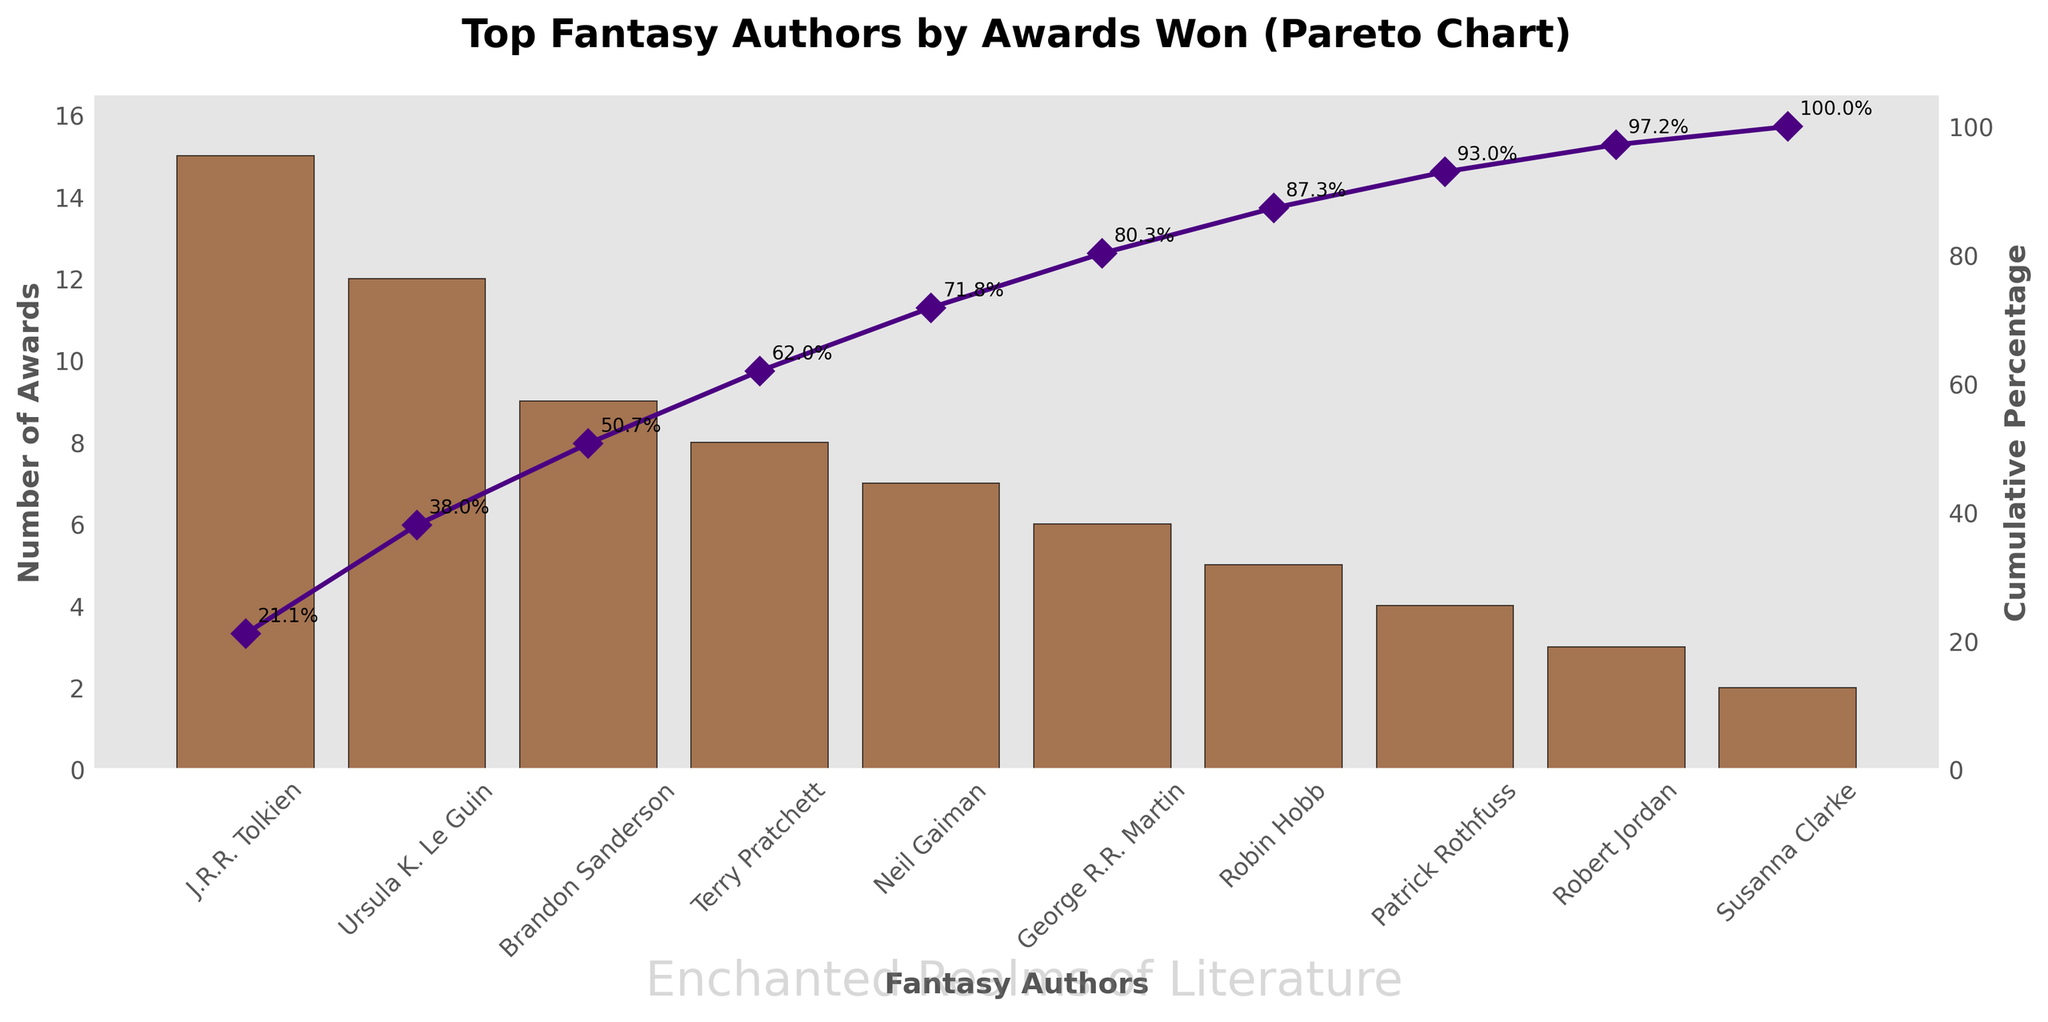What is the title of the chart? The title is found at the top of the chart. It gives an overall idea of what the chart is about.
Answer: Top Fantasy Authors by Awards Won (Pareto Chart) Who is the author with the most awards? The author with the highest bar represents the author with the most awards.
Answer: J.R.R. Tolkien How many awards has Neil Gaiman won? Locate the Neil Gaiman bar and read the corresponding number on the y-axis.
Answer: 7 What is the cumulative percentage of awards for the top three authors? Sum the awards of the top three authors (15 + 12 + 9 = 36), sum all awards (71), then calculate the percentage (36/71 * 100).
Answer: ~50.7% Name the authors who have won more awards than George R.R. Martin. Identify the authors with bars taller than George R.R. Martin's and list their corresponding names.
Answer: J.R.R. Tolkien, Ursula K. Le Guin, Brandon Sanderson, Terry Pratchett, Neil Gaiman Which author marks the 80% cumulative percentage threshold? Follow the cumulative percentage line on the figure until it reaches 80% and note the corresponding author.
Answer: Patrick Rothfuss How many total awards are represented in the chart? Add the number of awards for each author in the chart (15 + 12 + 9 + 8 + 7 + 6 + 5 + 4 + 3 + 2).
Answer: 71 Compare the awards won by Terry Pratchett and Robin Hobb. Subtract Robin Hobb's awards from Terry Pratchett's awards (8 - 5).
Answer: 3 What percentage of the total awards has Susanna Clarke won? Divide Susanna Clarke's awards by the total number of awards and multiply by 100 (2/71 * 100).
Answer: ~2.8% List the authors in descending order of the number of awards they have won. Sequence the authors by the height of their bars from tallest to shortest.
Answer: J.R.R. Tolkien, Ursula K. Le Guin, Brandon Sanderson, Terry Pratchett, Neil Gaiman, George R.R. Martin, Robin Hobb, Patrick Rothfuss, Robert Jordan, Susanna Clarke 